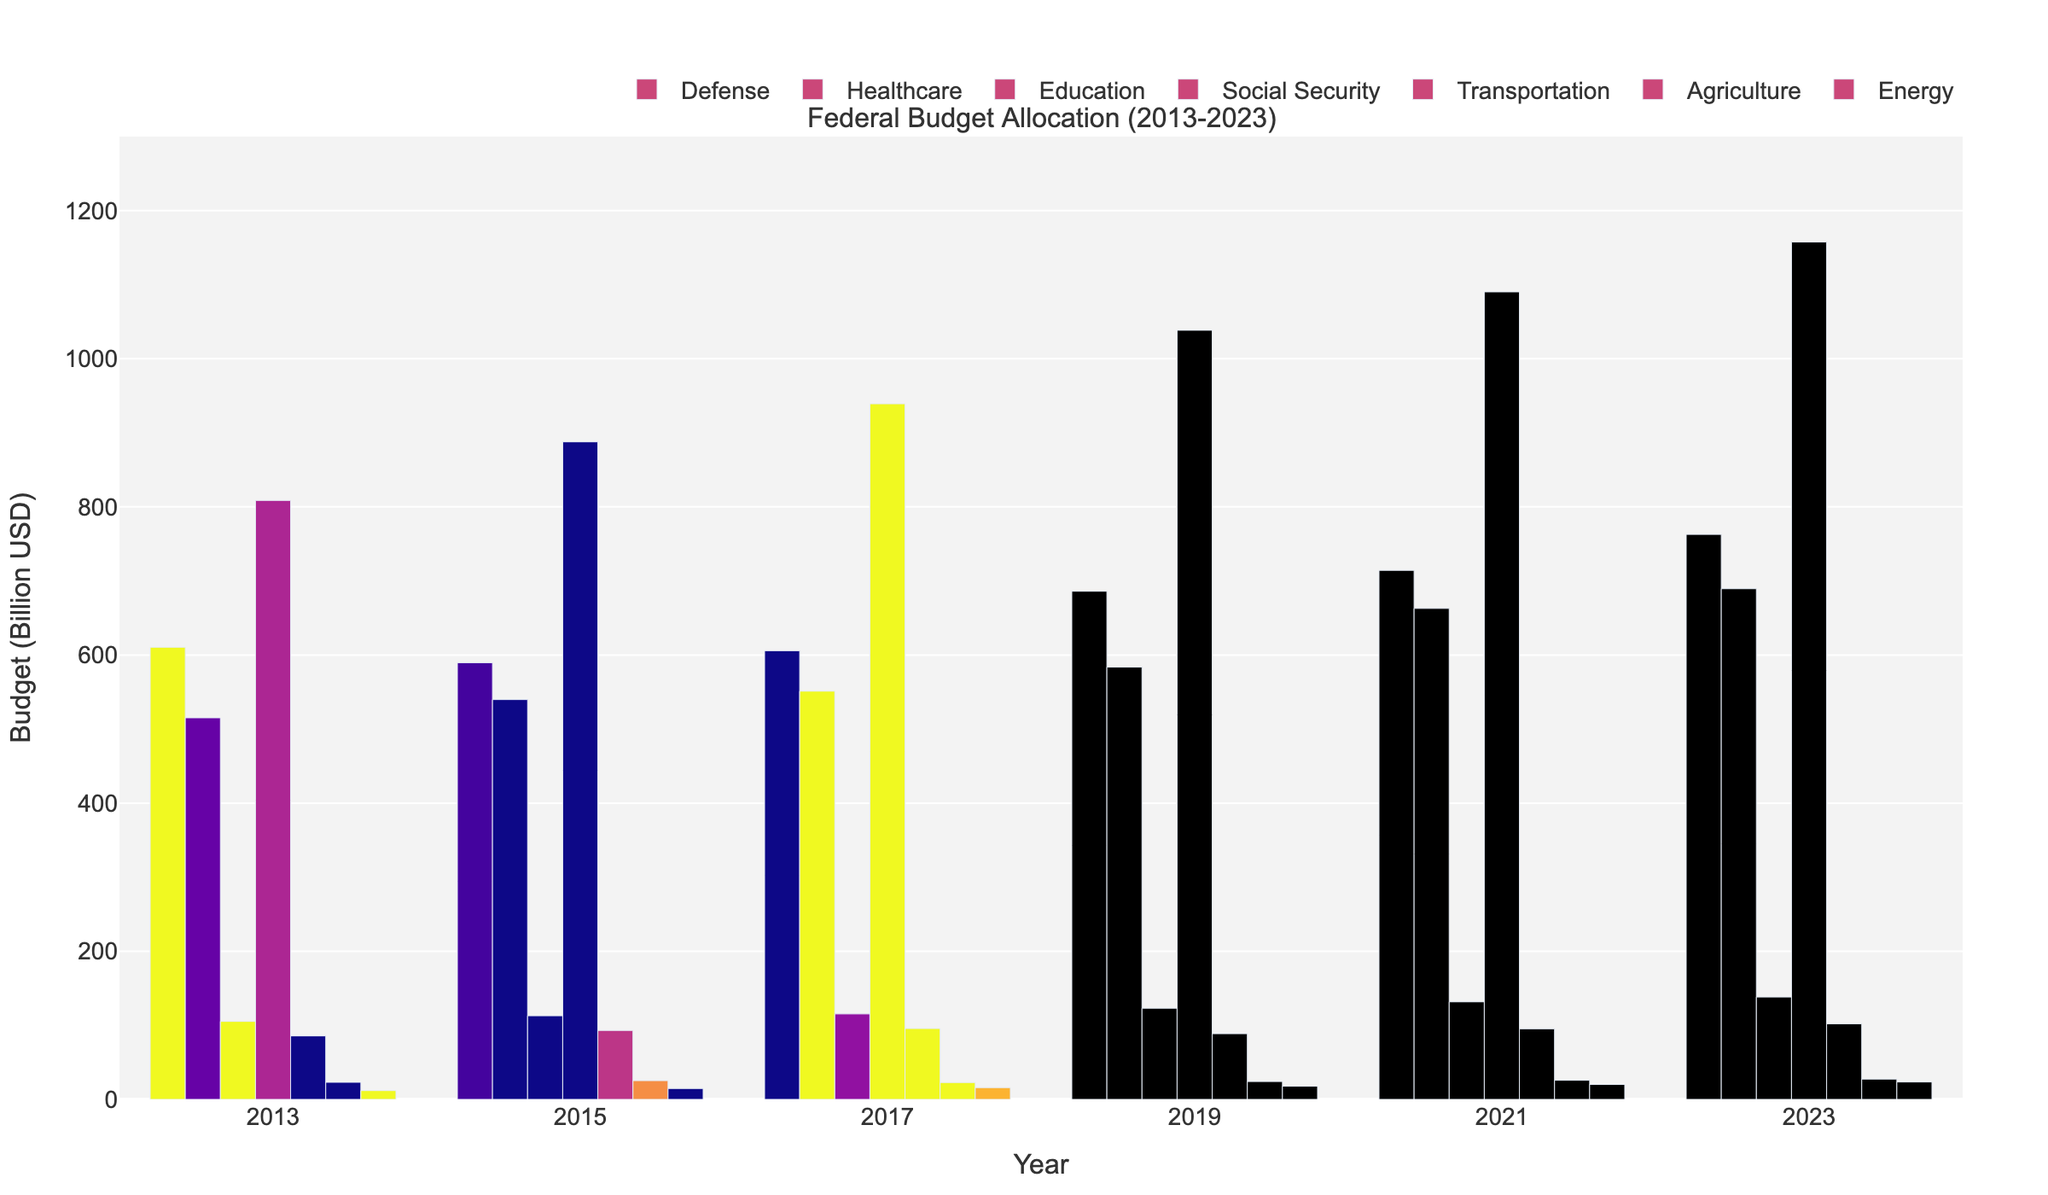Which sector saw the largest increase in budget allocation from 2013 to 2023? To find the sector with the largest increase, we calculate the difference between the 2023 and 2013 budgets for each sector and identify the largest difference: Defense (762.8 - 610.5 = 152.3), Healthcare (689.5 - 515.2 = 174.3), Education (138.2 - 105.3 = 32.9), Social Security (1157.6 - 808.7 = 348.9), Transportation (102.1 - 85.7 = 16.4), Agriculture (27.4 - 23.1 = 4.3), Energy (23.5 - 11.9 = 11.6). Social Security has the largest increase.
Answer: Social Security Which two sectors saw the smallest percentage increase in budget from 2013 to 2023? To determine the smallest percentage increase, calculate the percentage increase for each sector: Defense ((762.8-610.5)/610.5*100 ≈ 25%), Healthcare ((689.5-515.2)/515.2*100 ≈ 33.8%), Education ((138.2-105.3)/105.3*100 ≈ 31.3%), Social Security ((1157.6-808.7)/808.7*100 ≈ 43.1%), Transportation ((102.1-85.7)/85.7*100 ≈ 19.1%), Agriculture ((27.4-23.1)/23.1*100 ≈ 18.6%), Energy ((23.5-11.9)/11.9*100 ≈ 97.5%). Agriculture and Transportation saw the smallest percentage increases.
Answer: Agriculture, Transportation By how much did the Healthcare budget grow compared to the Defense budget from 2013 to 2023? Calculate the growth for both sectors from 2013 to 2023: Healthcare grew from 515.2 to 689.5 (an increase of 174.3 billion USD), and Defense grew from 610.5 to 762.8 (an increase of 152.3 billion USD). The difference in growth is 174.3 - 152.3 = 22 billion USD.
Answer: 22 billion USD In which year did Education see the smallest budget allocation, and what was the amount? To determine the year with the smallest Education budget, compare the values for each year: 2013 (105.3), 2015 (112.9), 2017 (115.4), 2019 (123.1), 2021 (131.7), 2023 (138.2). The smallest allocation was in 2013 with 105.3 billion USD.
Answer: 2013, 105.3 billion USD Which sector had the highest budget allocation in the latest year available (2023), and what was the amount? To find the sector with the highest allocation in 2023, compare the values for each sector: Defense (762.8), Healthcare (689.5), Education (138.2), Social Security (1157.6), Transportation (102.1), Agriculture (27.4), Energy (23.5). Social Security had the highest allocation with 1157.6 billion USD.
Answer: Social Security, 1157.6 billion USD What is the total budget allocation across all sectors in 2023? Sum the budget values for all sectors in 2023: 762.8 (Defense) + 689.5 (Healthcare) + 138.2 (Education) + 1157.6 (Social Security) + 102.1 (Transportation) + 27.4 (Agriculture) + 23.5 (Energy) = 2901.1 billion USD.
Answer: 2901.1 billion USD Which year saw the biggest increase in the Defense budget from the previous year listed? Calculate the increase for each year and find the largest: 2015-2013 (589.6-610.5 = -20.9), 2017-2015 (605.8-589.6 = 16.2), 2019-2017 (686.1-605.8 = 80.3), 2021-2019 (714.3-686.1 = 28.2), 2023-2021 (762.8-714.3 = 48.5). The biggest increase occurred between 2017 and 2019 with 80.3 billion USD.
Answer: 2017 to 2019, 80.3 billion USD Between 2013 and 2023, which sector had the most consistent (smallest fluctuations) budget increases? Calculate the year-to-year budget changes for each sector and determine the sector with the smallest variance in values: Defense (-20.9, 16.2, 80.3, 28.2, 48.5), Healthcare (24.6, 11.4, 32.5, 79.2, 26.6), Education (7.6, 2.5, 7.7, 8.6, 6.5), Social Security (79.1, 51.4, 99.3, 51.8, 67.3), Transportation (7.4, 2.6, -7.0, 6.6, 6.8), Agriculture (2.2, -2.5, 1.3, 1.7, 1.6), Energy (2.8, 1.2, 1.9, 2.4, 2.3). Education had the most consistent increases.
Answer: Education 